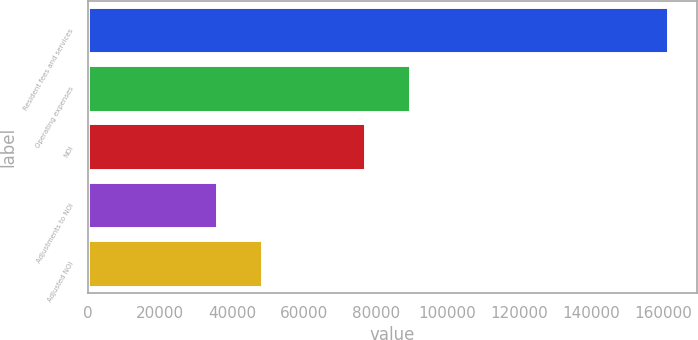<chart> <loc_0><loc_0><loc_500><loc_500><bar_chart><fcel>Resident fees and services<fcel>Operating expenses<fcel>NOI<fcel>Adjustments to NOI<fcel>Adjusted NOI<nl><fcel>161349<fcel>89513.6<fcel>76970<fcel>35913<fcel>48456.6<nl></chart> 